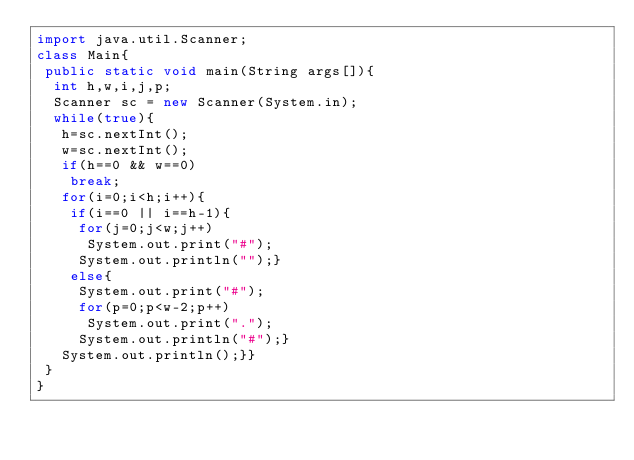<code> <loc_0><loc_0><loc_500><loc_500><_Java_>import java.util.Scanner;
class Main{
 public static void main(String args[]){
  int h,w,i,j,p;
  Scanner sc = new Scanner(System.in);
  while(true){
   h=sc.nextInt();
   w=sc.nextInt();
   if(h==0 && w==0)
    break;
   for(i=0;i<h;i++){
    if(i==0 || i==h-1){
     for(j=0;j<w;j++)
      System.out.print("#");
     System.out.println("");}
    else{
     System.out.print("#");
     for(p=0;p<w-2;p++)
      System.out.print(".");
     System.out.println("#");}
   System.out.println();}}
 }
}
</code> 